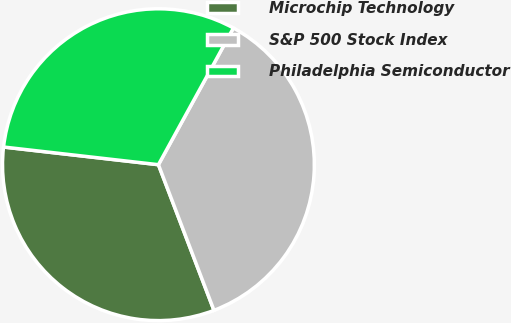Convert chart to OTSL. <chart><loc_0><loc_0><loc_500><loc_500><pie_chart><fcel>Microchip Technology<fcel>S&P 500 Stock Index<fcel>Philadelphia Semiconductor<nl><fcel>32.61%<fcel>36.22%<fcel>31.18%<nl></chart> 